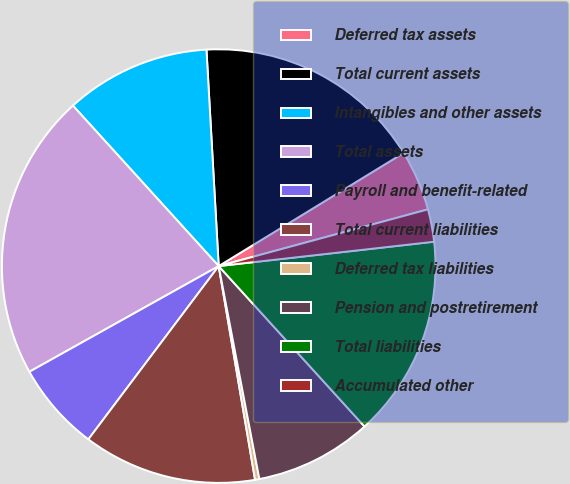Convert chart. <chart><loc_0><loc_0><loc_500><loc_500><pie_chart><fcel>Deferred tax assets<fcel>Total current assets<fcel>Intangibles and other assets<fcel>Total assets<fcel>Payroll and benefit-related<fcel>Total current liabilities<fcel>Deferred tax liabilities<fcel>Pension and postretirement<fcel>Total liabilities<fcel>Accumulated other<nl><fcel>4.53%<fcel>17.16%<fcel>10.84%<fcel>21.37%<fcel>6.63%<fcel>12.95%<fcel>0.32%<fcel>8.74%<fcel>15.05%<fcel>2.42%<nl></chart> 